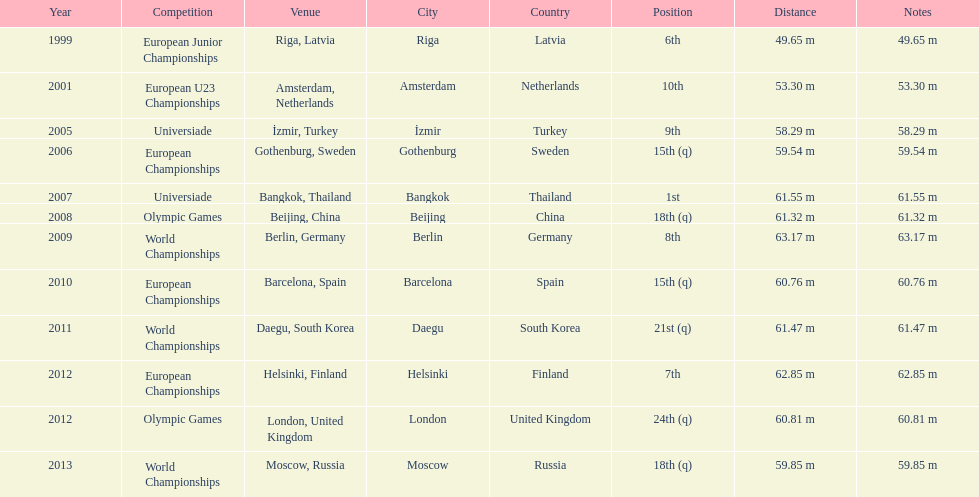Which year experienced the greatest number of contests? 2012. 